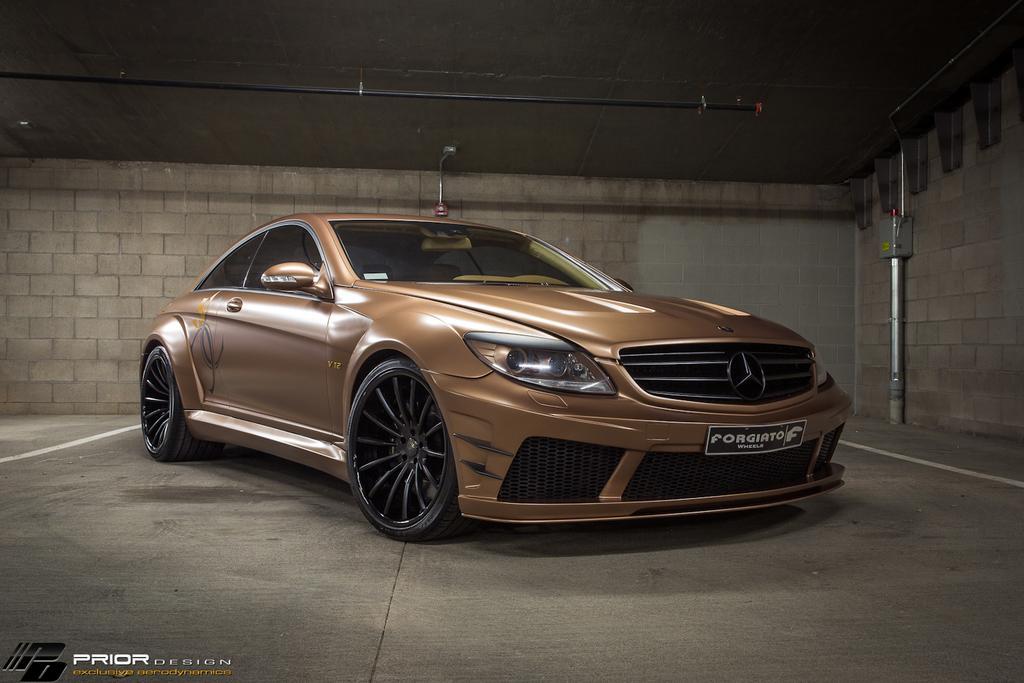Describe this image in one or two sentences. In this picture we can see a car in the front, in the background there is a wall, on the right side it looks like a pipe, there is a road at the top of the picture, at the left bottom we can see some text. 